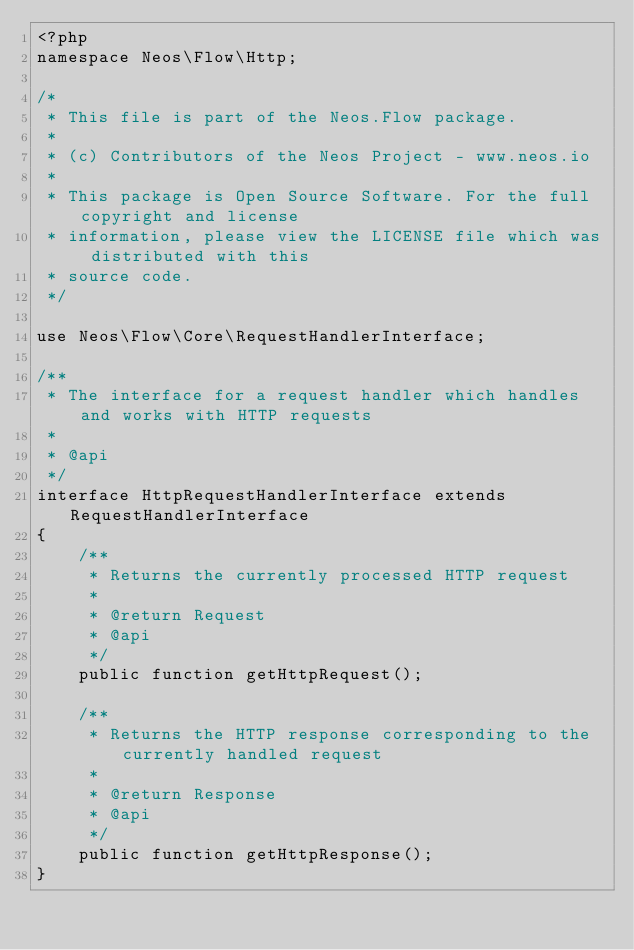Convert code to text. <code><loc_0><loc_0><loc_500><loc_500><_PHP_><?php
namespace Neos\Flow\Http;

/*
 * This file is part of the Neos.Flow package.
 *
 * (c) Contributors of the Neos Project - www.neos.io
 *
 * This package is Open Source Software. For the full copyright and license
 * information, please view the LICENSE file which was distributed with this
 * source code.
 */

use Neos\Flow\Core\RequestHandlerInterface;

/**
 * The interface for a request handler which handles and works with HTTP requests
 *
 * @api
 */
interface HttpRequestHandlerInterface extends RequestHandlerInterface
{
    /**
     * Returns the currently processed HTTP request
     *
     * @return Request
     * @api
     */
    public function getHttpRequest();

    /**
     * Returns the HTTP response corresponding to the currently handled request
     *
     * @return Response
     * @api
     */
    public function getHttpResponse();
}
</code> 